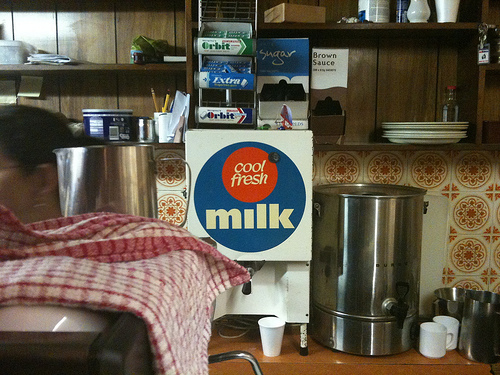<image>
Can you confirm if the milk dispenser is above the cup? Yes. The milk dispenser is positioned above the cup in the vertical space, higher up in the scene. Is the plate on the table? No. The plate is not positioned on the table. They may be near each other, but the plate is not supported by or resting on top of the table. 